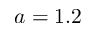<formula> <loc_0><loc_0><loc_500><loc_500>a = 1 . 2</formula> 